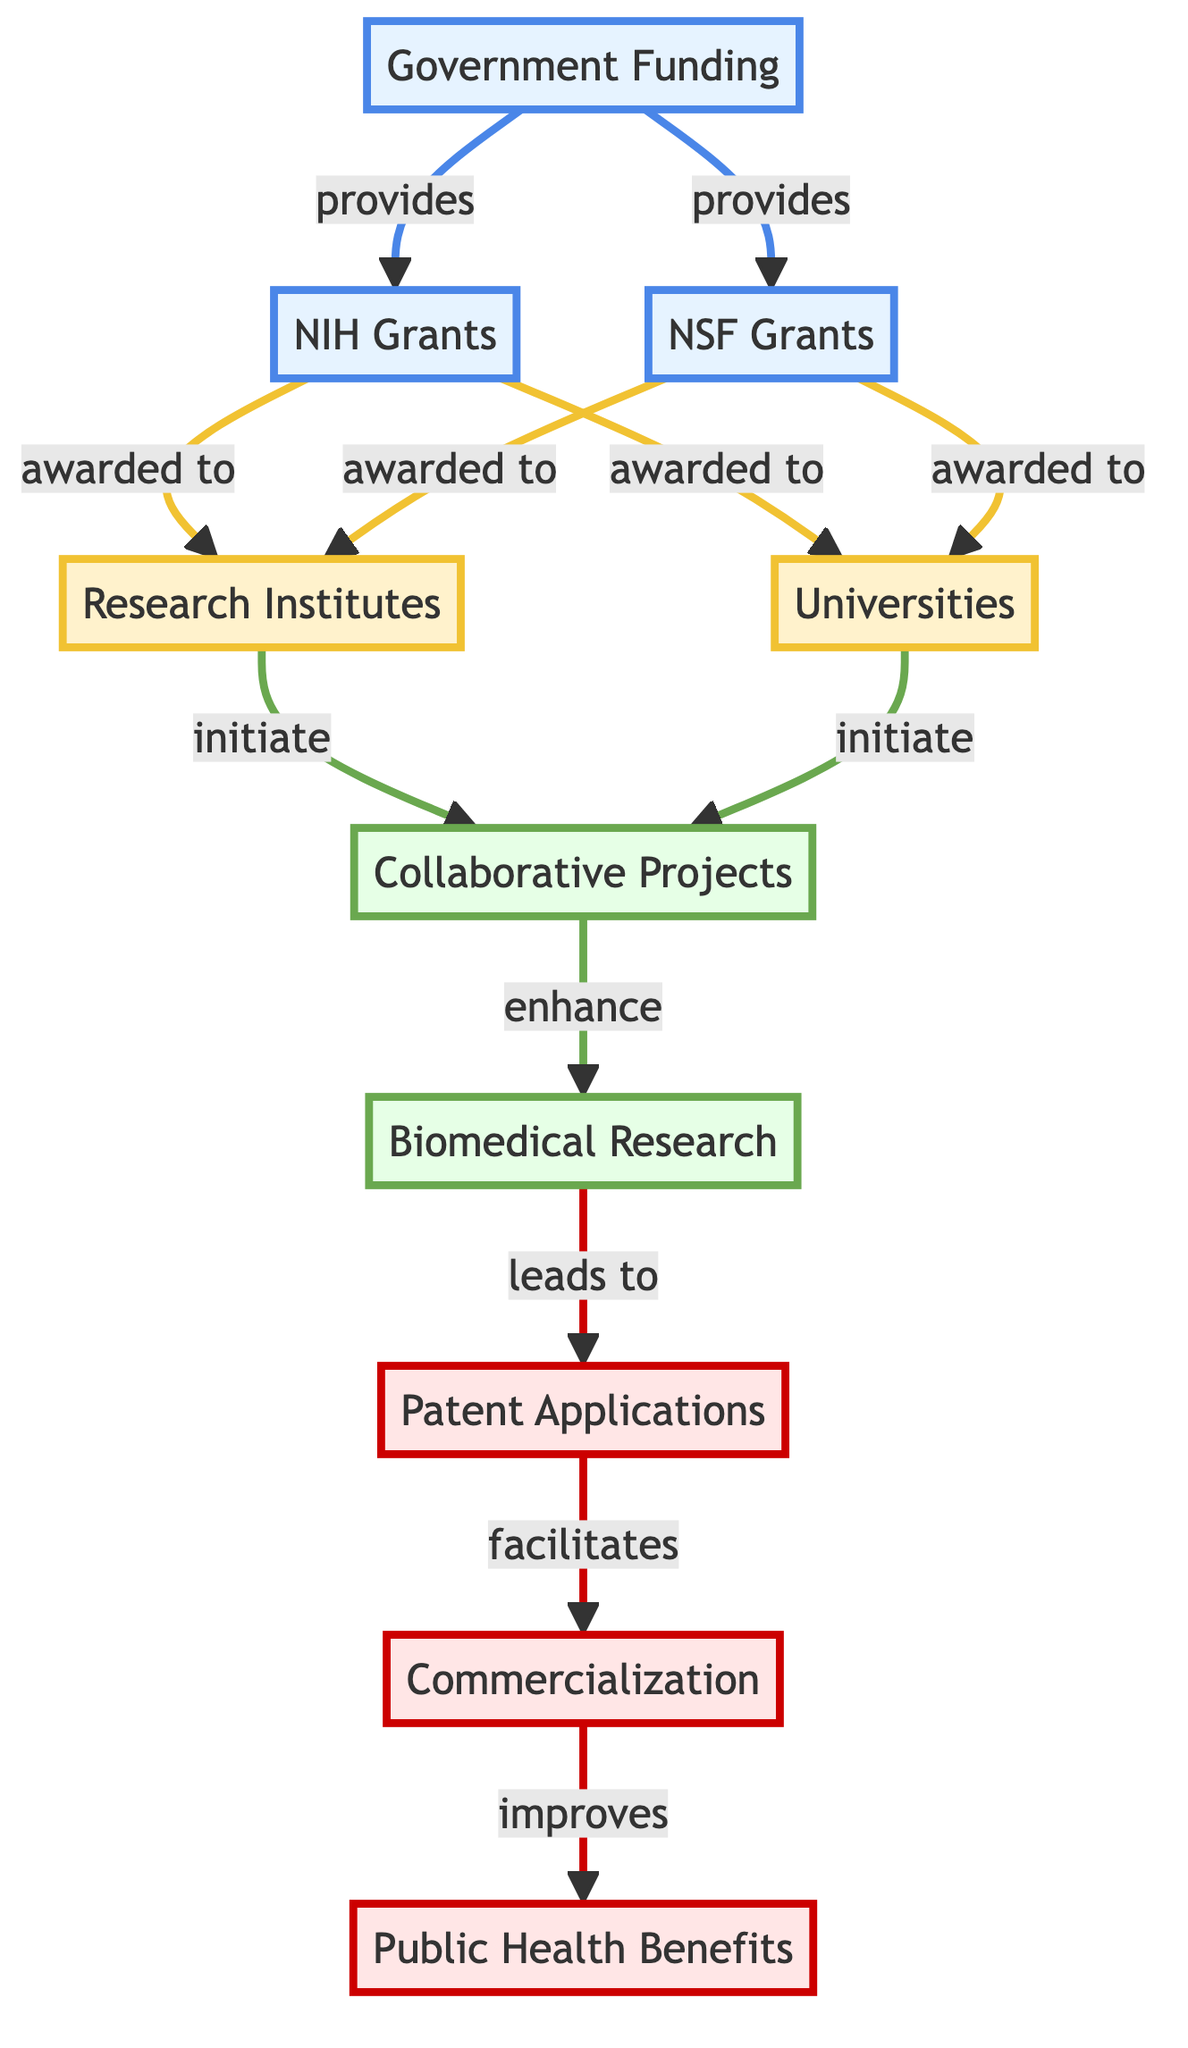What is the starting point of the diagram? The diagram starts with "Government Funding", which is represented at the top. It is the initial node from which other relationships branch out.
Answer: Government Funding How many types of grants are provided by the Government Funding? There are two types of grants shown in the diagram: NIH Grants and NSF Grants, both connected to the Government Funding node.
Answer: 2 Which entities receive NIH Grants? Both Research Institutes and Universities receive NIH Grants as indicated by the connections from the NIH Grants node.
Answer: Research Institutes and Universities What do Collaborative Projects enhance? Collaborative Projects enhance Biomedical Research, as shown by the directional arrow connecting these two nodes in the diagram.
Answer: Biomedical Research What is the final outcome represented in the diagram? The final outcome in the flow of the diagram is Public Health Benefits, which is the endpoint reached after following the various connections from Government Funding.
Answer: Public Health Benefits How does Patent Applications relate to Commercialization? Patent Applications facilitate Commercialization, suggesting that achieving patents is a supportive step towards the commercialization process depicted in the diagram.
Answer: facilitates What is the relationship between Research Institutes and Collaborative Projects? Research Institutes initiate Collaborative Projects, which means they are responsible for starting the projects in relation to the research activities depicted.
Answer: initiate How many nodes are classified under outcomes in the diagram? There are three nodes classified under outcomes: Patent Applications, Commercialization, and Public Health Benefits, as these represent the end results of the research process.
Answer: 3 What leads to Patent Applications according to the diagram? Biomedical Research leads to Patent Applications, indicating that successful research efforts can result in patent applications for new innovations.
Answer: leads to Which node has the most direct connections? The Government Funding node has the most direct connections as it branches out to both NIH and NSF Grants, which then connect to Research Institutes and Universities.
Answer: Government Funding 